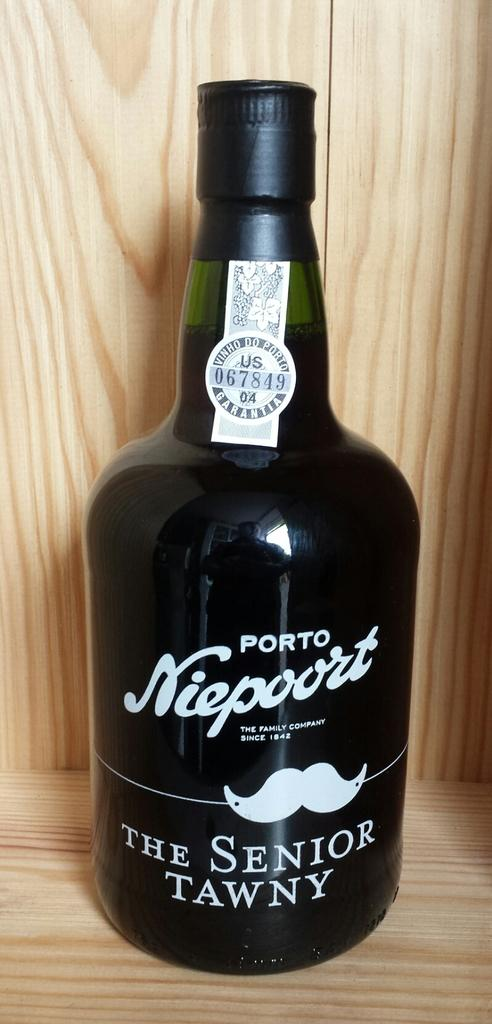Provide a one-sentence caption for the provided image. A bottle of The Senior Tawny Port stands in a wooden box. 